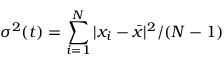Convert formula to latex. <formula><loc_0><loc_0><loc_500><loc_500>\sigma ^ { 2 } ( t ) = \sum _ { i = 1 } ^ { N } | x _ { i } - \bar { x } | ^ { 2 } / ( N - 1 )</formula> 